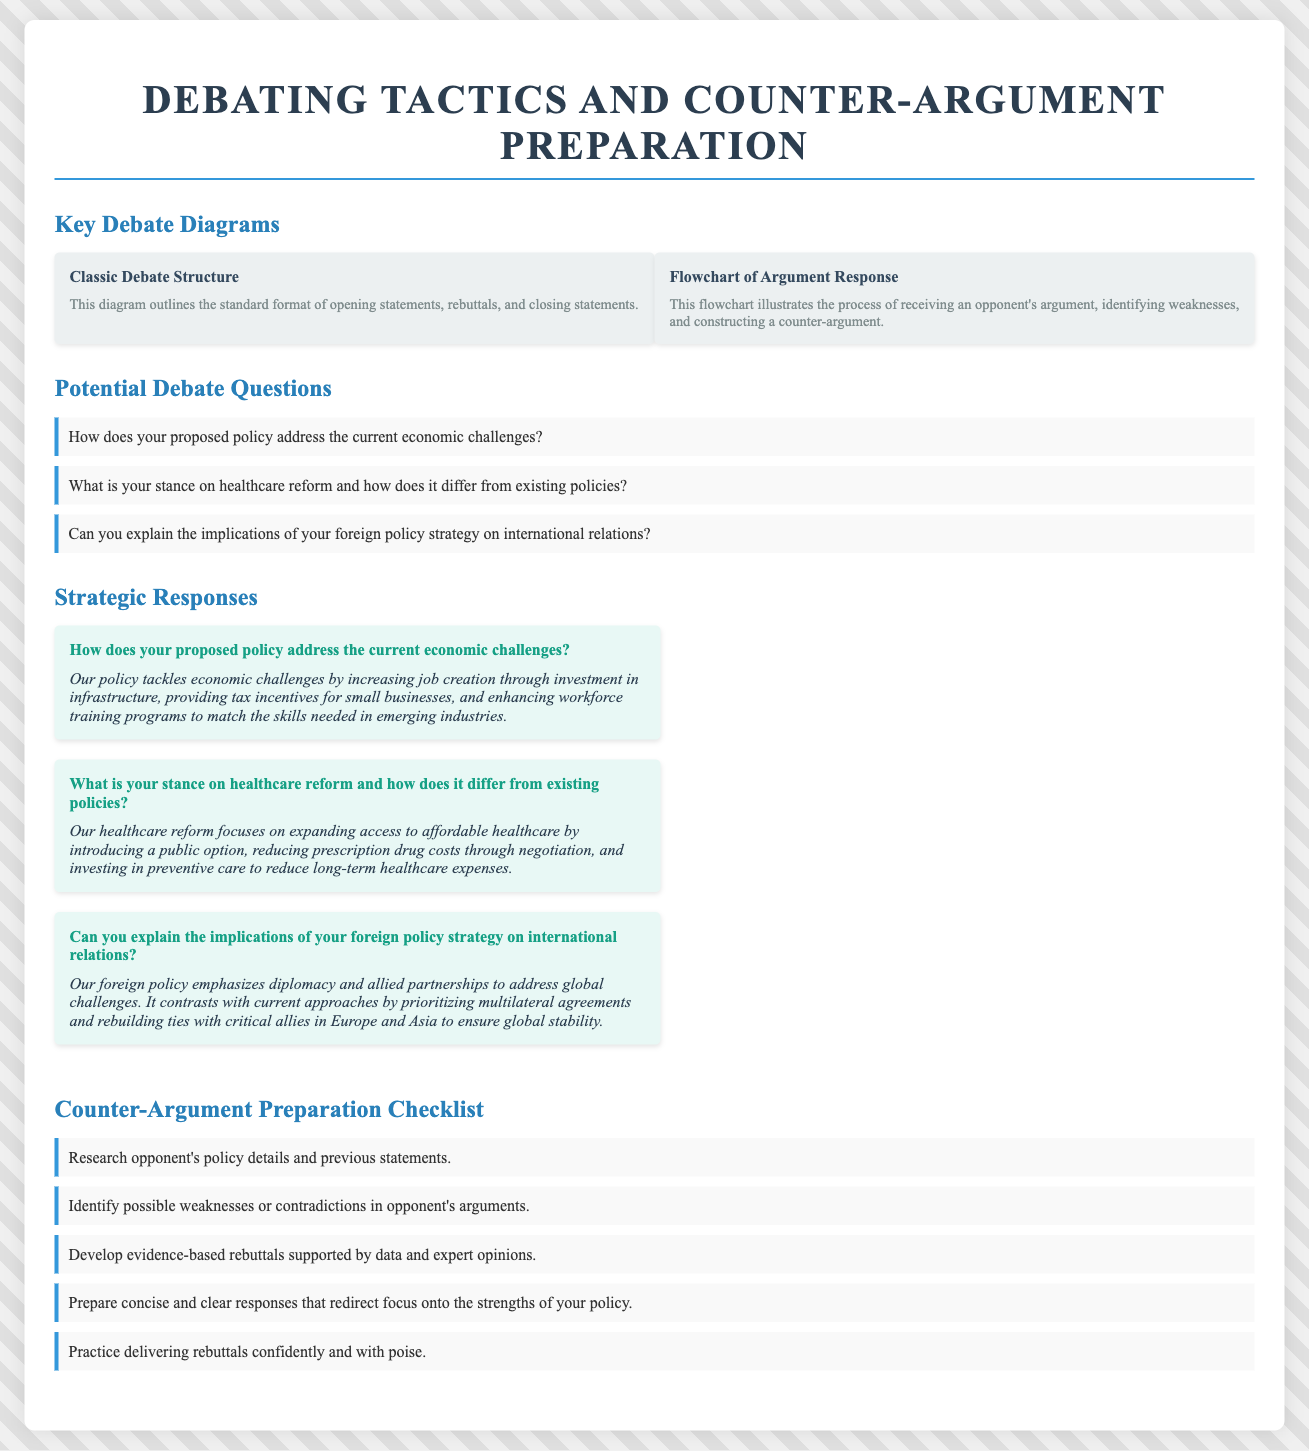What is the title of the document? The title appears at the top of the document and summarizes the main theme.
Answer: Debating Tactics and Counter-argument Preparation How many diagrams are presented in the document? There are two diagrams listed in the Key Debate Diagrams section.
Answer: 2 What is one question listed under Potential Debate Questions? The questions are specifically outlined in the Potential Debate Questions section.
Answer: How does your proposed policy address the current economic challenges? What is one strategic response provided in the document? The responses address the debate questions and are detailed in the Strategic Responses section.
Answer: Our policy tackles economic challenges by increasing job creation through investment in infrastructure What is the first item in the Counter-Argument Preparation Checklist? The items in the checklist are numbered and categorized in the checklist section.
Answer: Research opponent's policy details and previous statements What is the focus of the second diagram in the document? This is described in the second diagram's description, illustrating the flowchart's purpose.
Answer: The process of receiving an opponent's argument, identifying weaknesses, and constructing a counter-argument What color is used for the checklist items' border? The border color is distinctly indicated in the document's style for consistency.
Answer: #3498db What are the last two words of the first strategic response? These words can be found by reviewing the response text directly.
Answer: emerging industries 